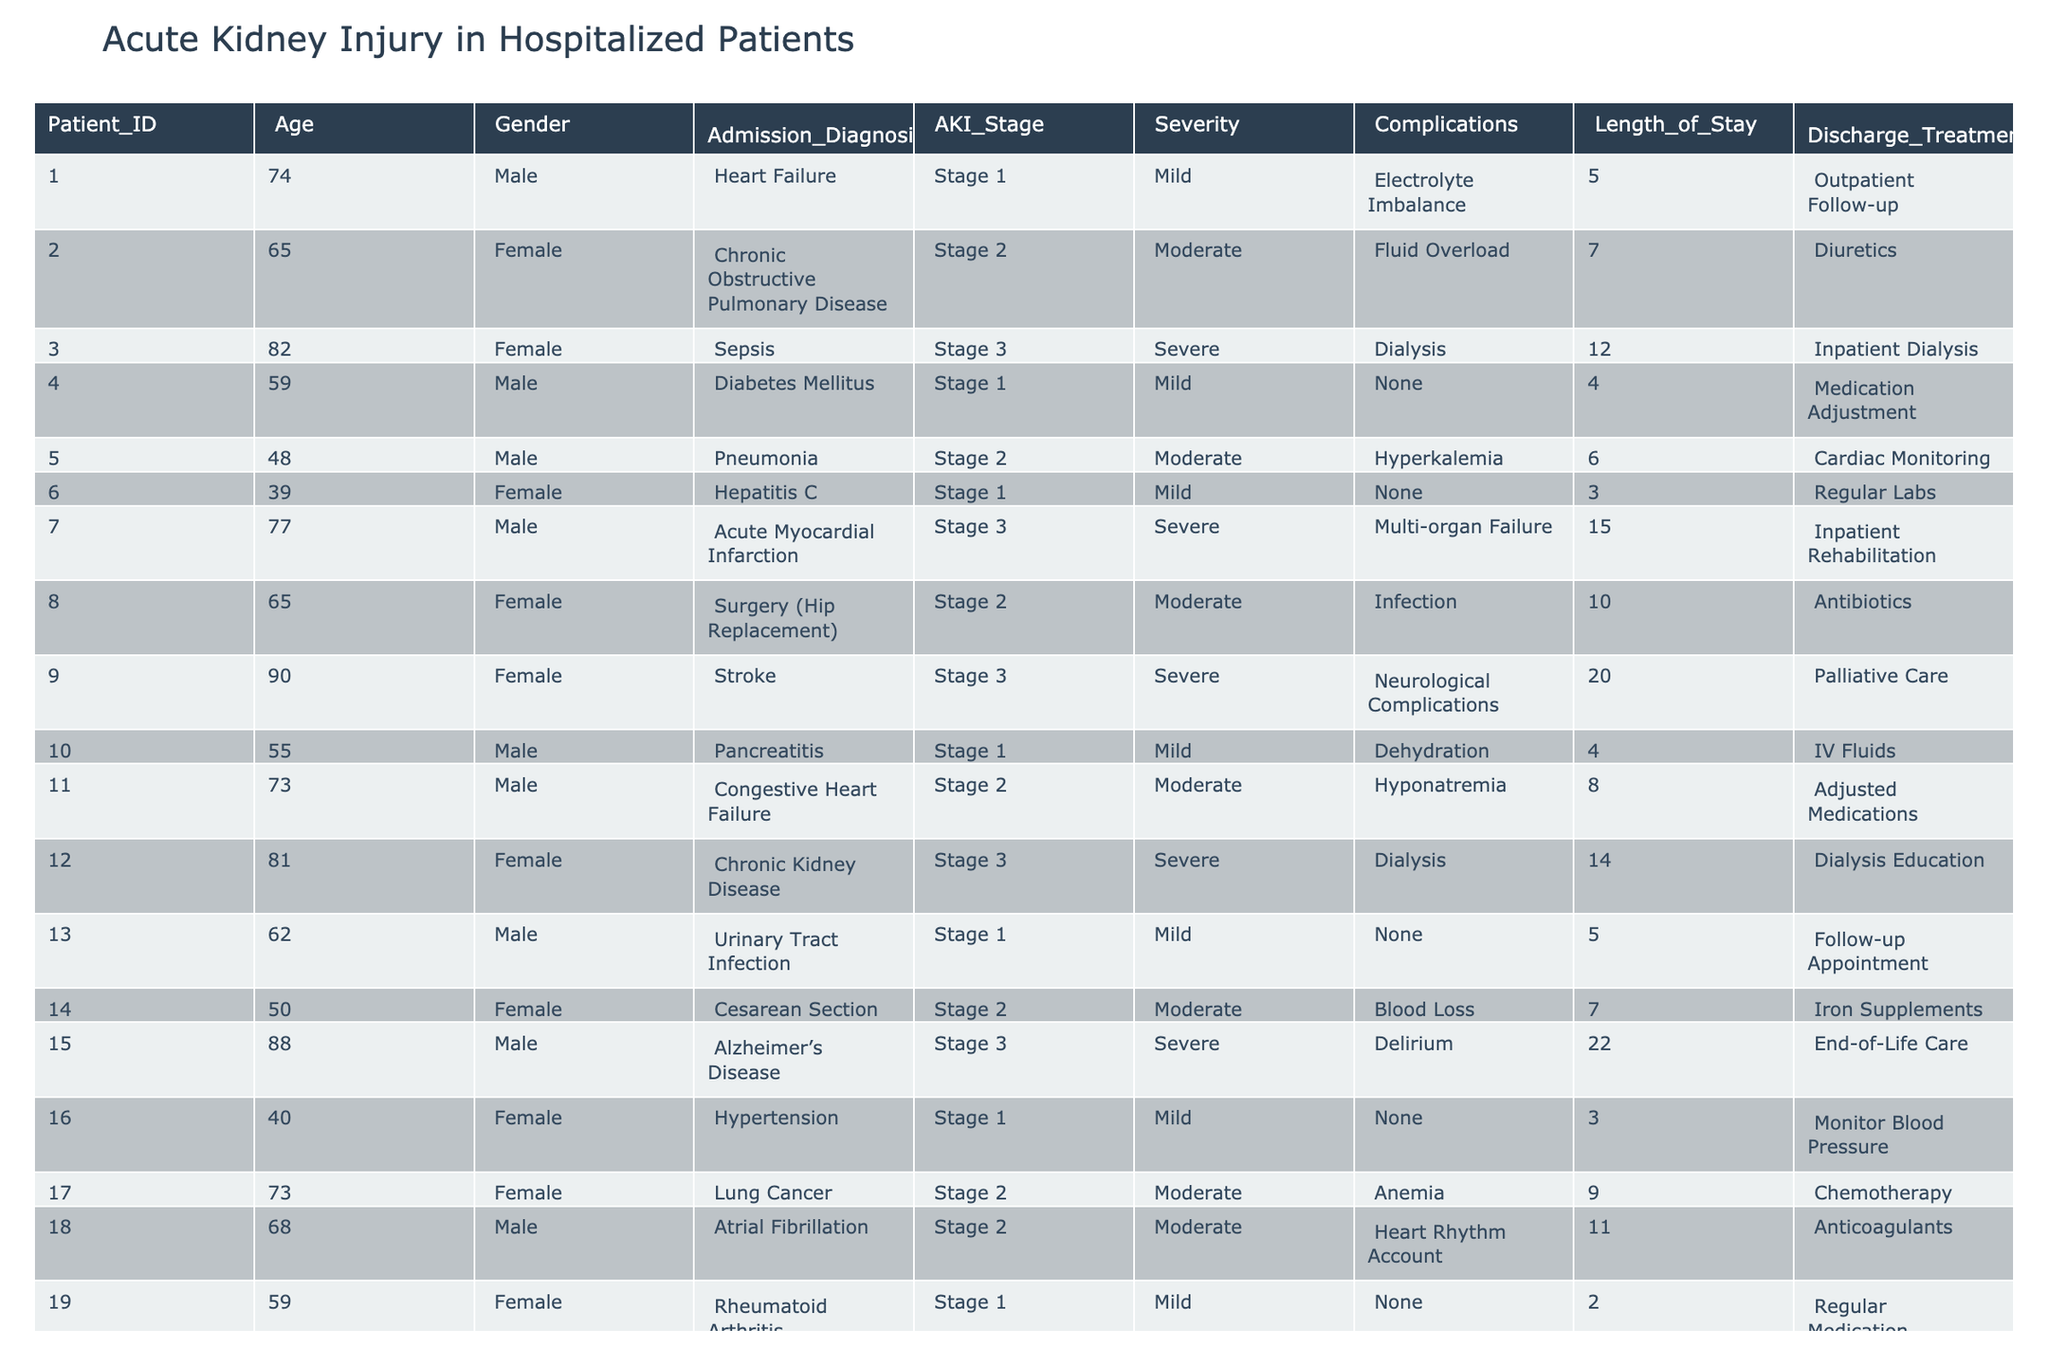What is the most common complication among the patients listed? By scanning the 'Complications' column, the repeated entries show that 'None' occurs multiple times. The next most common complications are 'Electrolyte Imbalance' and 'Fluid Overload' which appear less frequently.
Answer: None How many patients experienced severe AKI? Looking at the 'AKI_Stage' column, there are 7 entries that indicate 'Stage 3', which corresponds to severe AKI.
Answer: 7 What was the average length of stay for patients with stage 2 AKI? The 'Length_of_Stay' for patients with 'Stage 2' is 7, 6, 10, 8, 7, 9, and 11 days. Summing these gives 58 days. Dividing by the number of patients (7) results in 58/7 = approximately 8.29 days.
Answer: 8.3 days Is there a patient with a length of stay longer than 20 days? The 'Length_of_Stay' column was checked, and the maximum value is 22 days, which does exist for one patient.
Answer: Yes Which gender has the highest incidence of severe AKI based on the table data? Reviewing the 'AKI_Stage' column for 'Stage 3', three males (Patient_ID 007, 009, 020) and four females (Patient_ID 003, 012, 015, 009) are identified, which shows that females have a higher incidence.
Answer: Female What percentage of patients required dialysis as a complication? Counting the instances in the 'Complications' column, 3 patients are noted to require dialysis out of a total of 20 patients, which gives (3/20)*100 = 15%.
Answer: 15% What is the longest length of stay recorded for any patient with stage 1 AKI? The 'Length_of_Stay' for stage 1 AKI is observed in Patient_IDs 001, 004, 006, 010, 013, 016, and 019, which yields 5, 4, 3, 4, 5, 3, and 2 days. The maximum of these values is 5 days.
Answer: 5 days How many patients have ‘Fluid Overload’ as a complication? Scanning the 'Complications' category reveals that 'Fluid Overload' is reported once with Patient_ID 002, thus making the total count 1.
Answer: 1 Are there any patients aged over 80 who do not require dialysis? Checking the table shows that Patient_IDs 82 and 88 are over 80 years old but both have complications relating to serious conditions (dialysis required in one case), implying at least one requires dialysis.
Answer: No What is the total number of patients who had a complication of ‘Infection’? Reviewing the 'Complications' column, it shows 'Infection' appears only once for Patient_ID 008 resulting in a total count of 1.
Answer: 1 What can be inferred about the relationship between age and severity of AKI based on the data? Analyzing the data indicates older patients tend to belong to higher stages of AKI; those aged over 75 have a prevalence of stage 3, while younger patients are more frequently seen at stage 1.
Answer: Older patients have more severe AKI 